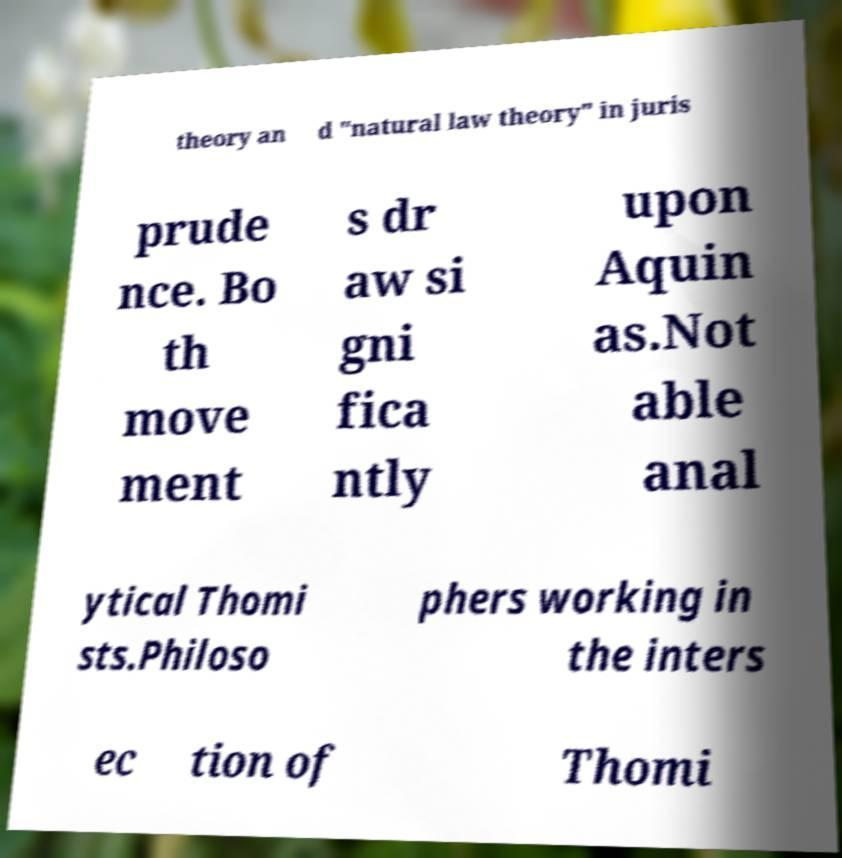For documentation purposes, I need the text within this image transcribed. Could you provide that? theory an d "natural law theory" in juris prude nce. Bo th move ment s dr aw si gni fica ntly upon Aquin as.Not able anal ytical Thomi sts.Philoso phers working in the inters ec tion of Thomi 